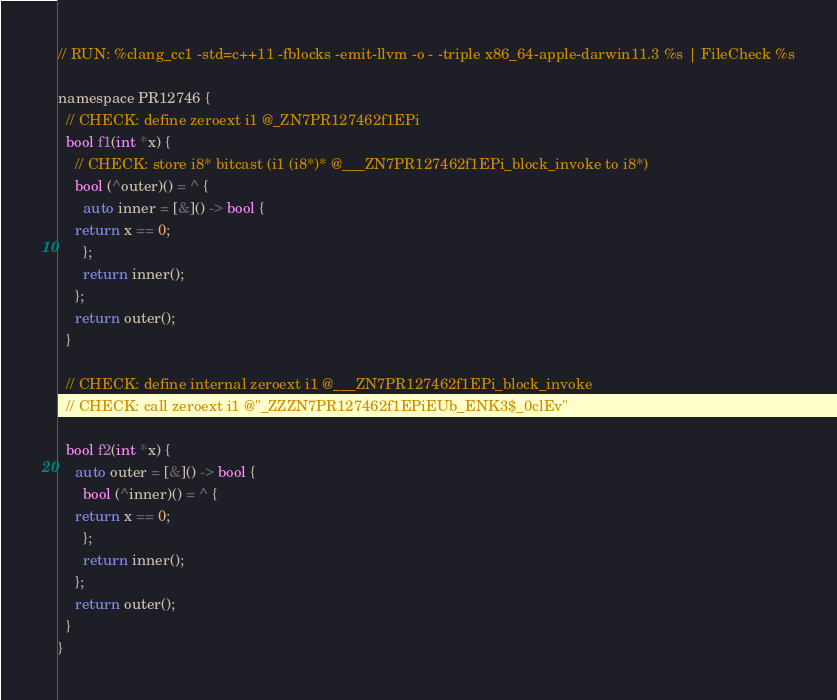<code> <loc_0><loc_0><loc_500><loc_500><_ObjectiveC_>// RUN: %clang_cc1 -std=c++11 -fblocks -emit-llvm -o - -triple x86_64-apple-darwin11.3 %s | FileCheck %s

namespace PR12746 {
  // CHECK: define zeroext i1 @_ZN7PR127462f1EPi
  bool f1(int *x) {
    // CHECK: store i8* bitcast (i1 (i8*)* @___ZN7PR127462f1EPi_block_invoke to i8*)
    bool (^outer)() = ^ {
      auto inner = [&]() -> bool {
	return x == 0;
      };
      return inner();
    };
    return outer();
  }

  // CHECK: define internal zeroext i1 @___ZN7PR127462f1EPi_block_invoke
  // CHECK: call zeroext i1 @"_ZZZN7PR127462f1EPiEUb_ENK3$_0clEv"

  bool f2(int *x) {
    auto outer = [&]() -> bool {
      bool (^inner)() = ^ {
	return x == 0;
      };
      return inner();
    };
    return outer();
  }
}

</code> 